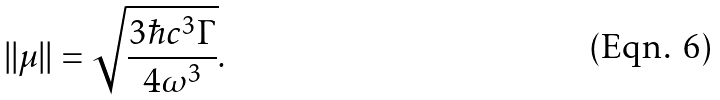<formula> <loc_0><loc_0><loc_500><loc_500>| | \mu | | = \sqrt { \frac { 3 \hbar { c } ^ { 3 } \Gamma } { 4 \omega ^ { 3 } } } .</formula> 